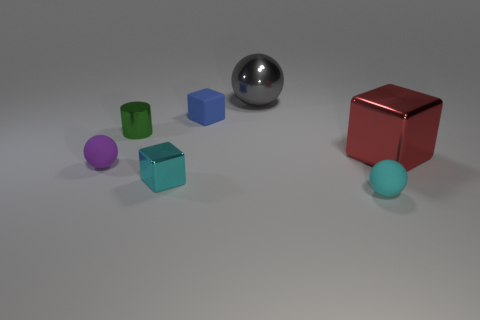What is the color of the small metallic object that is the same shape as the large red metal object?
Give a very brief answer. Cyan. Does the small ball to the right of the tiny green shiny thing have the same color as the small metallic block?
Offer a terse response. Yes. Is the size of the gray metal ball the same as the red metal block?
Keep it short and to the point. Yes. What is the shape of the other big object that is made of the same material as the large red thing?
Your answer should be compact. Sphere. What number of other things are there of the same shape as the tiny purple rubber object?
Your response must be concise. 2. There is a tiny cyan thing that is right of the big shiny object that is on the left side of the cube right of the gray shiny thing; what shape is it?
Provide a short and direct response. Sphere. What number of cubes are large red things or tiny blue things?
Provide a short and direct response. 2. Are there any gray metallic spheres left of the green cylinder in front of the blue thing?
Provide a succinct answer. No. Are there any other things that are the same material as the big cube?
Keep it short and to the point. Yes. There is a tiny green thing; does it have the same shape as the small matte thing in front of the tiny purple rubber sphere?
Ensure brevity in your answer.  No. 